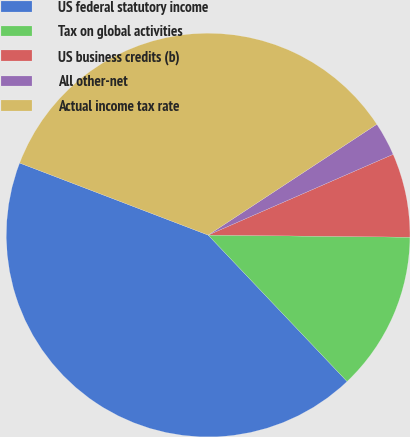<chart> <loc_0><loc_0><loc_500><loc_500><pie_chart><fcel>US federal statutory income<fcel>Tax on global activities<fcel>US business credits (b)<fcel>All other-net<fcel>Actual income tax rate<nl><fcel>42.9%<fcel>12.75%<fcel>6.72%<fcel>2.7%<fcel>34.94%<nl></chart> 